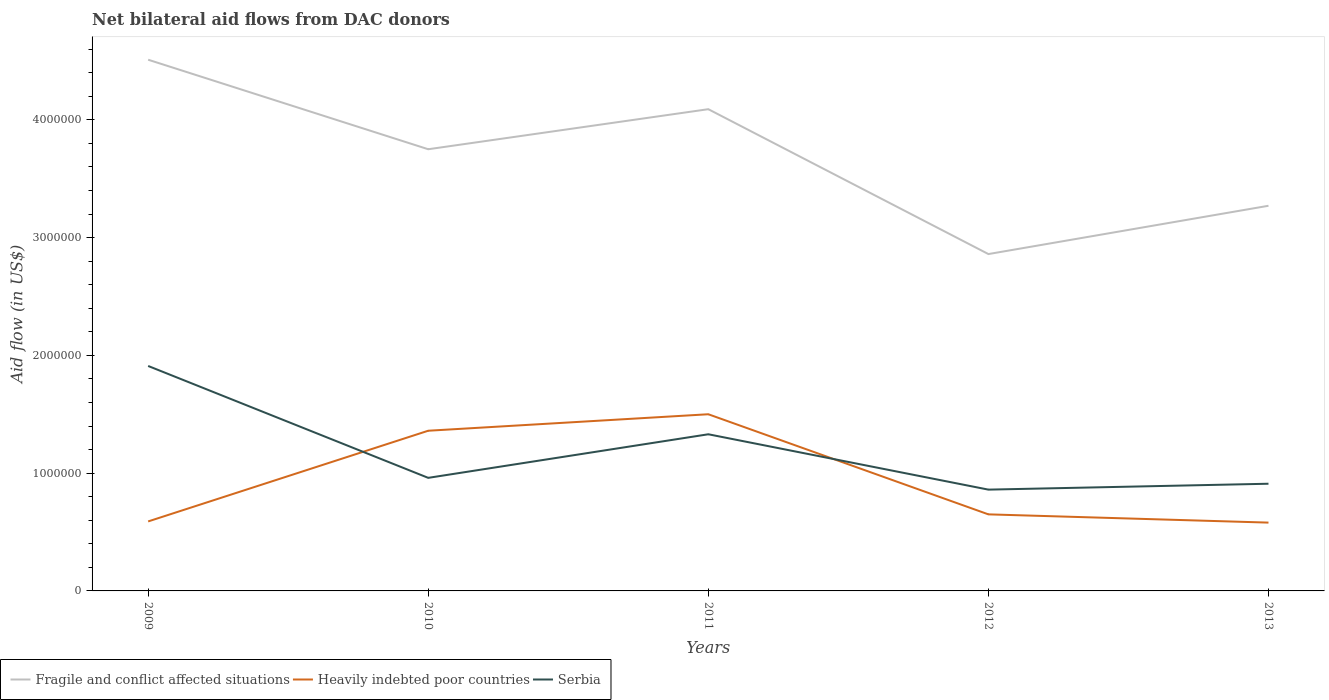How many different coloured lines are there?
Your response must be concise. 3. Does the line corresponding to Serbia intersect with the line corresponding to Fragile and conflict affected situations?
Make the answer very short. No. Across all years, what is the maximum net bilateral aid flow in Heavily indebted poor countries?
Offer a very short reply. 5.80e+05. In which year was the net bilateral aid flow in Heavily indebted poor countries maximum?
Your response must be concise. 2013. What is the total net bilateral aid flow in Serbia in the graph?
Keep it short and to the point. 4.70e+05. What is the difference between the highest and the second highest net bilateral aid flow in Serbia?
Give a very brief answer. 1.05e+06. Does the graph contain any zero values?
Provide a succinct answer. No. How are the legend labels stacked?
Your answer should be compact. Horizontal. What is the title of the graph?
Your answer should be very brief. Net bilateral aid flows from DAC donors. What is the label or title of the Y-axis?
Provide a succinct answer. Aid flow (in US$). What is the Aid flow (in US$) in Fragile and conflict affected situations in 2009?
Make the answer very short. 4.51e+06. What is the Aid flow (in US$) of Heavily indebted poor countries in 2009?
Offer a very short reply. 5.90e+05. What is the Aid flow (in US$) in Serbia in 2009?
Provide a short and direct response. 1.91e+06. What is the Aid flow (in US$) in Fragile and conflict affected situations in 2010?
Offer a terse response. 3.75e+06. What is the Aid flow (in US$) in Heavily indebted poor countries in 2010?
Keep it short and to the point. 1.36e+06. What is the Aid flow (in US$) in Serbia in 2010?
Provide a succinct answer. 9.60e+05. What is the Aid flow (in US$) of Fragile and conflict affected situations in 2011?
Your answer should be very brief. 4.09e+06. What is the Aid flow (in US$) in Heavily indebted poor countries in 2011?
Make the answer very short. 1.50e+06. What is the Aid flow (in US$) of Serbia in 2011?
Make the answer very short. 1.33e+06. What is the Aid flow (in US$) in Fragile and conflict affected situations in 2012?
Your answer should be compact. 2.86e+06. What is the Aid flow (in US$) of Heavily indebted poor countries in 2012?
Make the answer very short. 6.50e+05. What is the Aid flow (in US$) of Serbia in 2012?
Provide a short and direct response. 8.60e+05. What is the Aid flow (in US$) of Fragile and conflict affected situations in 2013?
Your answer should be very brief. 3.27e+06. What is the Aid flow (in US$) of Heavily indebted poor countries in 2013?
Your response must be concise. 5.80e+05. What is the Aid flow (in US$) in Serbia in 2013?
Provide a short and direct response. 9.10e+05. Across all years, what is the maximum Aid flow (in US$) in Fragile and conflict affected situations?
Offer a terse response. 4.51e+06. Across all years, what is the maximum Aid flow (in US$) in Heavily indebted poor countries?
Provide a succinct answer. 1.50e+06. Across all years, what is the maximum Aid flow (in US$) in Serbia?
Your answer should be very brief. 1.91e+06. Across all years, what is the minimum Aid flow (in US$) of Fragile and conflict affected situations?
Provide a short and direct response. 2.86e+06. Across all years, what is the minimum Aid flow (in US$) of Heavily indebted poor countries?
Your answer should be compact. 5.80e+05. Across all years, what is the minimum Aid flow (in US$) of Serbia?
Ensure brevity in your answer.  8.60e+05. What is the total Aid flow (in US$) of Fragile and conflict affected situations in the graph?
Offer a terse response. 1.85e+07. What is the total Aid flow (in US$) of Heavily indebted poor countries in the graph?
Ensure brevity in your answer.  4.68e+06. What is the total Aid flow (in US$) of Serbia in the graph?
Make the answer very short. 5.97e+06. What is the difference between the Aid flow (in US$) of Fragile and conflict affected situations in 2009 and that in 2010?
Your answer should be very brief. 7.60e+05. What is the difference between the Aid flow (in US$) in Heavily indebted poor countries in 2009 and that in 2010?
Your answer should be compact. -7.70e+05. What is the difference between the Aid flow (in US$) in Serbia in 2009 and that in 2010?
Make the answer very short. 9.50e+05. What is the difference between the Aid flow (in US$) in Fragile and conflict affected situations in 2009 and that in 2011?
Your answer should be very brief. 4.20e+05. What is the difference between the Aid flow (in US$) of Heavily indebted poor countries in 2009 and that in 2011?
Make the answer very short. -9.10e+05. What is the difference between the Aid flow (in US$) in Serbia in 2009 and that in 2011?
Offer a terse response. 5.80e+05. What is the difference between the Aid flow (in US$) of Fragile and conflict affected situations in 2009 and that in 2012?
Give a very brief answer. 1.65e+06. What is the difference between the Aid flow (in US$) of Serbia in 2009 and that in 2012?
Your answer should be compact. 1.05e+06. What is the difference between the Aid flow (in US$) in Fragile and conflict affected situations in 2009 and that in 2013?
Your answer should be very brief. 1.24e+06. What is the difference between the Aid flow (in US$) of Heavily indebted poor countries in 2010 and that in 2011?
Offer a terse response. -1.40e+05. What is the difference between the Aid flow (in US$) in Serbia in 2010 and that in 2011?
Offer a terse response. -3.70e+05. What is the difference between the Aid flow (in US$) in Fragile and conflict affected situations in 2010 and that in 2012?
Keep it short and to the point. 8.90e+05. What is the difference between the Aid flow (in US$) in Heavily indebted poor countries in 2010 and that in 2012?
Keep it short and to the point. 7.10e+05. What is the difference between the Aid flow (in US$) in Fragile and conflict affected situations in 2010 and that in 2013?
Your response must be concise. 4.80e+05. What is the difference between the Aid flow (in US$) in Heavily indebted poor countries in 2010 and that in 2013?
Your answer should be very brief. 7.80e+05. What is the difference between the Aid flow (in US$) in Fragile and conflict affected situations in 2011 and that in 2012?
Make the answer very short. 1.23e+06. What is the difference between the Aid flow (in US$) in Heavily indebted poor countries in 2011 and that in 2012?
Give a very brief answer. 8.50e+05. What is the difference between the Aid flow (in US$) in Serbia in 2011 and that in 2012?
Offer a terse response. 4.70e+05. What is the difference between the Aid flow (in US$) of Fragile and conflict affected situations in 2011 and that in 2013?
Offer a terse response. 8.20e+05. What is the difference between the Aid flow (in US$) in Heavily indebted poor countries in 2011 and that in 2013?
Offer a terse response. 9.20e+05. What is the difference between the Aid flow (in US$) of Fragile and conflict affected situations in 2012 and that in 2013?
Keep it short and to the point. -4.10e+05. What is the difference between the Aid flow (in US$) of Fragile and conflict affected situations in 2009 and the Aid flow (in US$) of Heavily indebted poor countries in 2010?
Offer a terse response. 3.15e+06. What is the difference between the Aid flow (in US$) in Fragile and conflict affected situations in 2009 and the Aid flow (in US$) in Serbia in 2010?
Your answer should be compact. 3.55e+06. What is the difference between the Aid flow (in US$) in Heavily indebted poor countries in 2009 and the Aid flow (in US$) in Serbia in 2010?
Your response must be concise. -3.70e+05. What is the difference between the Aid flow (in US$) of Fragile and conflict affected situations in 2009 and the Aid flow (in US$) of Heavily indebted poor countries in 2011?
Provide a short and direct response. 3.01e+06. What is the difference between the Aid flow (in US$) of Fragile and conflict affected situations in 2009 and the Aid flow (in US$) of Serbia in 2011?
Keep it short and to the point. 3.18e+06. What is the difference between the Aid flow (in US$) of Heavily indebted poor countries in 2009 and the Aid flow (in US$) of Serbia in 2011?
Make the answer very short. -7.40e+05. What is the difference between the Aid flow (in US$) in Fragile and conflict affected situations in 2009 and the Aid flow (in US$) in Heavily indebted poor countries in 2012?
Give a very brief answer. 3.86e+06. What is the difference between the Aid flow (in US$) of Fragile and conflict affected situations in 2009 and the Aid flow (in US$) of Serbia in 2012?
Offer a very short reply. 3.65e+06. What is the difference between the Aid flow (in US$) of Heavily indebted poor countries in 2009 and the Aid flow (in US$) of Serbia in 2012?
Offer a terse response. -2.70e+05. What is the difference between the Aid flow (in US$) in Fragile and conflict affected situations in 2009 and the Aid flow (in US$) in Heavily indebted poor countries in 2013?
Give a very brief answer. 3.93e+06. What is the difference between the Aid flow (in US$) in Fragile and conflict affected situations in 2009 and the Aid flow (in US$) in Serbia in 2013?
Make the answer very short. 3.60e+06. What is the difference between the Aid flow (in US$) in Heavily indebted poor countries in 2009 and the Aid flow (in US$) in Serbia in 2013?
Provide a short and direct response. -3.20e+05. What is the difference between the Aid flow (in US$) of Fragile and conflict affected situations in 2010 and the Aid flow (in US$) of Heavily indebted poor countries in 2011?
Offer a very short reply. 2.25e+06. What is the difference between the Aid flow (in US$) of Fragile and conflict affected situations in 2010 and the Aid flow (in US$) of Serbia in 2011?
Give a very brief answer. 2.42e+06. What is the difference between the Aid flow (in US$) in Heavily indebted poor countries in 2010 and the Aid flow (in US$) in Serbia in 2011?
Keep it short and to the point. 3.00e+04. What is the difference between the Aid flow (in US$) of Fragile and conflict affected situations in 2010 and the Aid flow (in US$) of Heavily indebted poor countries in 2012?
Make the answer very short. 3.10e+06. What is the difference between the Aid flow (in US$) of Fragile and conflict affected situations in 2010 and the Aid flow (in US$) of Serbia in 2012?
Your answer should be very brief. 2.89e+06. What is the difference between the Aid flow (in US$) in Heavily indebted poor countries in 2010 and the Aid flow (in US$) in Serbia in 2012?
Your answer should be very brief. 5.00e+05. What is the difference between the Aid flow (in US$) in Fragile and conflict affected situations in 2010 and the Aid flow (in US$) in Heavily indebted poor countries in 2013?
Provide a short and direct response. 3.17e+06. What is the difference between the Aid flow (in US$) of Fragile and conflict affected situations in 2010 and the Aid flow (in US$) of Serbia in 2013?
Make the answer very short. 2.84e+06. What is the difference between the Aid flow (in US$) in Heavily indebted poor countries in 2010 and the Aid flow (in US$) in Serbia in 2013?
Your answer should be very brief. 4.50e+05. What is the difference between the Aid flow (in US$) in Fragile and conflict affected situations in 2011 and the Aid flow (in US$) in Heavily indebted poor countries in 2012?
Offer a very short reply. 3.44e+06. What is the difference between the Aid flow (in US$) in Fragile and conflict affected situations in 2011 and the Aid flow (in US$) in Serbia in 2012?
Your answer should be compact. 3.23e+06. What is the difference between the Aid flow (in US$) of Heavily indebted poor countries in 2011 and the Aid flow (in US$) of Serbia in 2012?
Your response must be concise. 6.40e+05. What is the difference between the Aid flow (in US$) of Fragile and conflict affected situations in 2011 and the Aid flow (in US$) of Heavily indebted poor countries in 2013?
Give a very brief answer. 3.51e+06. What is the difference between the Aid flow (in US$) of Fragile and conflict affected situations in 2011 and the Aid flow (in US$) of Serbia in 2013?
Your response must be concise. 3.18e+06. What is the difference between the Aid flow (in US$) of Heavily indebted poor countries in 2011 and the Aid flow (in US$) of Serbia in 2013?
Keep it short and to the point. 5.90e+05. What is the difference between the Aid flow (in US$) in Fragile and conflict affected situations in 2012 and the Aid flow (in US$) in Heavily indebted poor countries in 2013?
Your answer should be compact. 2.28e+06. What is the difference between the Aid flow (in US$) of Fragile and conflict affected situations in 2012 and the Aid flow (in US$) of Serbia in 2013?
Your answer should be compact. 1.95e+06. What is the difference between the Aid flow (in US$) of Heavily indebted poor countries in 2012 and the Aid flow (in US$) of Serbia in 2013?
Provide a succinct answer. -2.60e+05. What is the average Aid flow (in US$) of Fragile and conflict affected situations per year?
Your answer should be compact. 3.70e+06. What is the average Aid flow (in US$) of Heavily indebted poor countries per year?
Your answer should be very brief. 9.36e+05. What is the average Aid flow (in US$) in Serbia per year?
Provide a short and direct response. 1.19e+06. In the year 2009, what is the difference between the Aid flow (in US$) in Fragile and conflict affected situations and Aid flow (in US$) in Heavily indebted poor countries?
Your response must be concise. 3.92e+06. In the year 2009, what is the difference between the Aid flow (in US$) of Fragile and conflict affected situations and Aid flow (in US$) of Serbia?
Keep it short and to the point. 2.60e+06. In the year 2009, what is the difference between the Aid flow (in US$) of Heavily indebted poor countries and Aid flow (in US$) of Serbia?
Provide a short and direct response. -1.32e+06. In the year 2010, what is the difference between the Aid flow (in US$) of Fragile and conflict affected situations and Aid flow (in US$) of Heavily indebted poor countries?
Your response must be concise. 2.39e+06. In the year 2010, what is the difference between the Aid flow (in US$) of Fragile and conflict affected situations and Aid flow (in US$) of Serbia?
Give a very brief answer. 2.79e+06. In the year 2010, what is the difference between the Aid flow (in US$) of Heavily indebted poor countries and Aid flow (in US$) of Serbia?
Offer a very short reply. 4.00e+05. In the year 2011, what is the difference between the Aid flow (in US$) of Fragile and conflict affected situations and Aid flow (in US$) of Heavily indebted poor countries?
Ensure brevity in your answer.  2.59e+06. In the year 2011, what is the difference between the Aid flow (in US$) in Fragile and conflict affected situations and Aid flow (in US$) in Serbia?
Provide a succinct answer. 2.76e+06. In the year 2011, what is the difference between the Aid flow (in US$) of Heavily indebted poor countries and Aid flow (in US$) of Serbia?
Offer a very short reply. 1.70e+05. In the year 2012, what is the difference between the Aid flow (in US$) of Fragile and conflict affected situations and Aid flow (in US$) of Heavily indebted poor countries?
Make the answer very short. 2.21e+06. In the year 2013, what is the difference between the Aid flow (in US$) of Fragile and conflict affected situations and Aid flow (in US$) of Heavily indebted poor countries?
Ensure brevity in your answer.  2.69e+06. In the year 2013, what is the difference between the Aid flow (in US$) in Fragile and conflict affected situations and Aid flow (in US$) in Serbia?
Offer a very short reply. 2.36e+06. In the year 2013, what is the difference between the Aid flow (in US$) of Heavily indebted poor countries and Aid flow (in US$) of Serbia?
Ensure brevity in your answer.  -3.30e+05. What is the ratio of the Aid flow (in US$) in Fragile and conflict affected situations in 2009 to that in 2010?
Offer a terse response. 1.2. What is the ratio of the Aid flow (in US$) of Heavily indebted poor countries in 2009 to that in 2010?
Your response must be concise. 0.43. What is the ratio of the Aid flow (in US$) of Serbia in 2009 to that in 2010?
Provide a succinct answer. 1.99. What is the ratio of the Aid flow (in US$) of Fragile and conflict affected situations in 2009 to that in 2011?
Provide a short and direct response. 1.1. What is the ratio of the Aid flow (in US$) of Heavily indebted poor countries in 2009 to that in 2011?
Provide a succinct answer. 0.39. What is the ratio of the Aid flow (in US$) of Serbia in 2009 to that in 2011?
Give a very brief answer. 1.44. What is the ratio of the Aid flow (in US$) of Fragile and conflict affected situations in 2009 to that in 2012?
Offer a terse response. 1.58. What is the ratio of the Aid flow (in US$) in Heavily indebted poor countries in 2009 to that in 2012?
Offer a very short reply. 0.91. What is the ratio of the Aid flow (in US$) in Serbia in 2009 to that in 2012?
Your response must be concise. 2.22. What is the ratio of the Aid flow (in US$) of Fragile and conflict affected situations in 2009 to that in 2013?
Your answer should be very brief. 1.38. What is the ratio of the Aid flow (in US$) in Heavily indebted poor countries in 2009 to that in 2013?
Offer a very short reply. 1.02. What is the ratio of the Aid flow (in US$) of Serbia in 2009 to that in 2013?
Offer a very short reply. 2.1. What is the ratio of the Aid flow (in US$) in Fragile and conflict affected situations in 2010 to that in 2011?
Give a very brief answer. 0.92. What is the ratio of the Aid flow (in US$) of Heavily indebted poor countries in 2010 to that in 2011?
Your response must be concise. 0.91. What is the ratio of the Aid flow (in US$) of Serbia in 2010 to that in 2011?
Keep it short and to the point. 0.72. What is the ratio of the Aid flow (in US$) of Fragile and conflict affected situations in 2010 to that in 2012?
Give a very brief answer. 1.31. What is the ratio of the Aid flow (in US$) in Heavily indebted poor countries in 2010 to that in 2012?
Provide a short and direct response. 2.09. What is the ratio of the Aid flow (in US$) of Serbia in 2010 to that in 2012?
Your answer should be compact. 1.12. What is the ratio of the Aid flow (in US$) of Fragile and conflict affected situations in 2010 to that in 2013?
Your response must be concise. 1.15. What is the ratio of the Aid flow (in US$) of Heavily indebted poor countries in 2010 to that in 2013?
Your answer should be compact. 2.34. What is the ratio of the Aid flow (in US$) of Serbia in 2010 to that in 2013?
Your response must be concise. 1.05. What is the ratio of the Aid flow (in US$) of Fragile and conflict affected situations in 2011 to that in 2012?
Offer a very short reply. 1.43. What is the ratio of the Aid flow (in US$) of Heavily indebted poor countries in 2011 to that in 2012?
Your answer should be very brief. 2.31. What is the ratio of the Aid flow (in US$) of Serbia in 2011 to that in 2012?
Offer a terse response. 1.55. What is the ratio of the Aid flow (in US$) of Fragile and conflict affected situations in 2011 to that in 2013?
Provide a short and direct response. 1.25. What is the ratio of the Aid flow (in US$) of Heavily indebted poor countries in 2011 to that in 2013?
Provide a short and direct response. 2.59. What is the ratio of the Aid flow (in US$) of Serbia in 2011 to that in 2013?
Your answer should be compact. 1.46. What is the ratio of the Aid flow (in US$) in Fragile and conflict affected situations in 2012 to that in 2013?
Ensure brevity in your answer.  0.87. What is the ratio of the Aid flow (in US$) of Heavily indebted poor countries in 2012 to that in 2013?
Ensure brevity in your answer.  1.12. What is the ratio of the Aid flow (in US$) in Serbia in 2012 to that in 2013?
Ensure brevity in your answer.  0.95. What is the difference between the highest and the second highest Aid flow (in US$) of Heavily indebted poor countries?
Give a very brief answer. 1.40e+05. What is the difference between the highest and the second highest Aid flow (in US$) of Serbia?
Keep it short and to the point. 5.80e+05. What is the difference between the highest and the lowest Aid flow (in US$) of Fragile and conflict affected situations?
Give a very brief answer. 1.65e+06. What is the difference between the highest and the lowest Aid flow (in US$) in Heavily indebted poor countries?
Keep it short and to the point. 9.20e+05. What is the difference between the highest and the lowest Aid flow (in US$) in Serbia?
Give a very brief answer. 1.05e+06. 